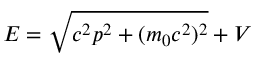Convert formula to latex. <formula><loc_0><loc_0><loc_500><loc_500>E = { \sqrt { c ^ { 2 } p ^ { 2 } + ( m _ { 0 } c ^ { 2 } ) ^ { 2 } } } + V</formula> 